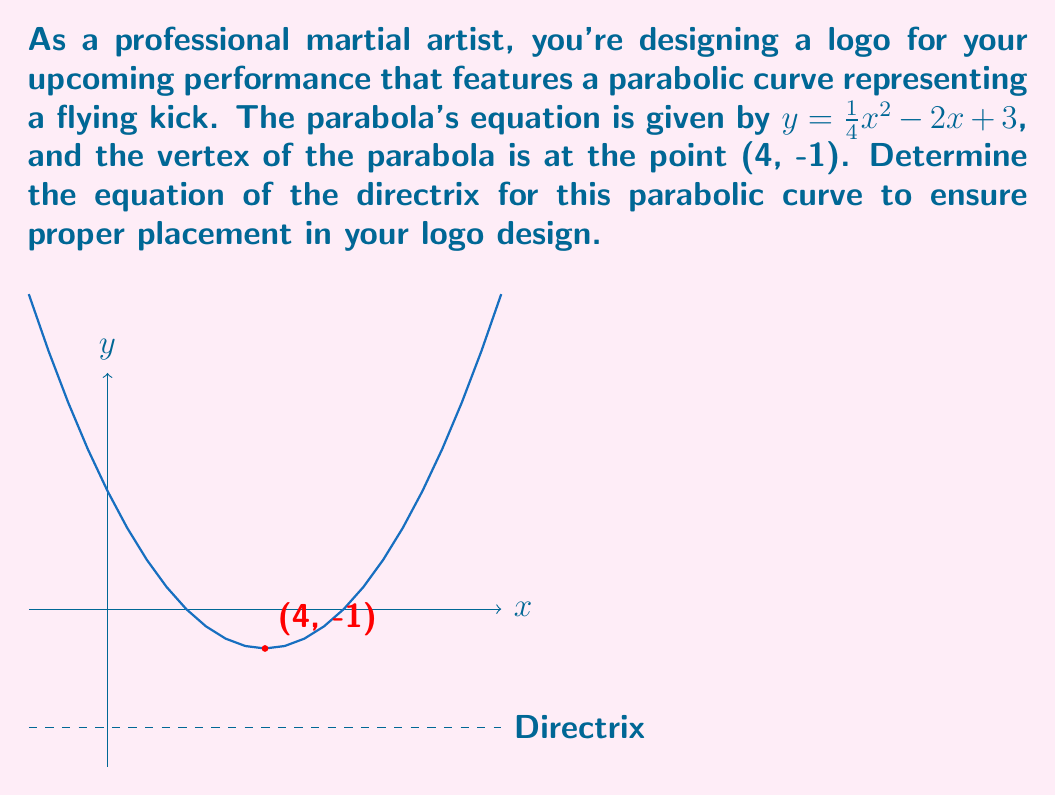Provide a solution to this math problem. Let's approach this step-by-step:

1) The general form of a parabola with vertex $(h,k)$ is:
   $y = a(x-h)^2 + k$

2) From the given equation $y = \frac{1}{4}x^2 - 2x + 3$, we can identify $a = \frac{1}{4}$

3) We're also given the vertex (4, -1), so $h = 4$ and $k = -1$

4) For a parabola with equation $y = a(x-h)^2 + k$, the distance from the vertex to the directrix is given by $\frac{1}{4a}$

5) Substituting our value for $a$:
   Distance = $\frac{1}{4(\frac{1}{4})} = 1$

6) Since the parabola opens upward (positive $a$), the directrix is below the vertex

7) The directrix is a horizontal line 1 unit below the vertex

8) The y-coordinate of the directrix will be:
   $y = k - \frac{1}{4a} = -1 - 1 = -2$

9) Therefore, the equation of the directrix is $y = -2$
Answer: $y = -2$ 